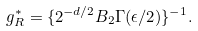<formula> <loc_0><loc_0><loc_500><loc_500>g _ { R } ^ { \ast } = \{ 2 ^ { - d / 2 } B _ { 2 } \Gamma ( \epsilon / 2 ) \} ^ { - 1 } .</formula> 